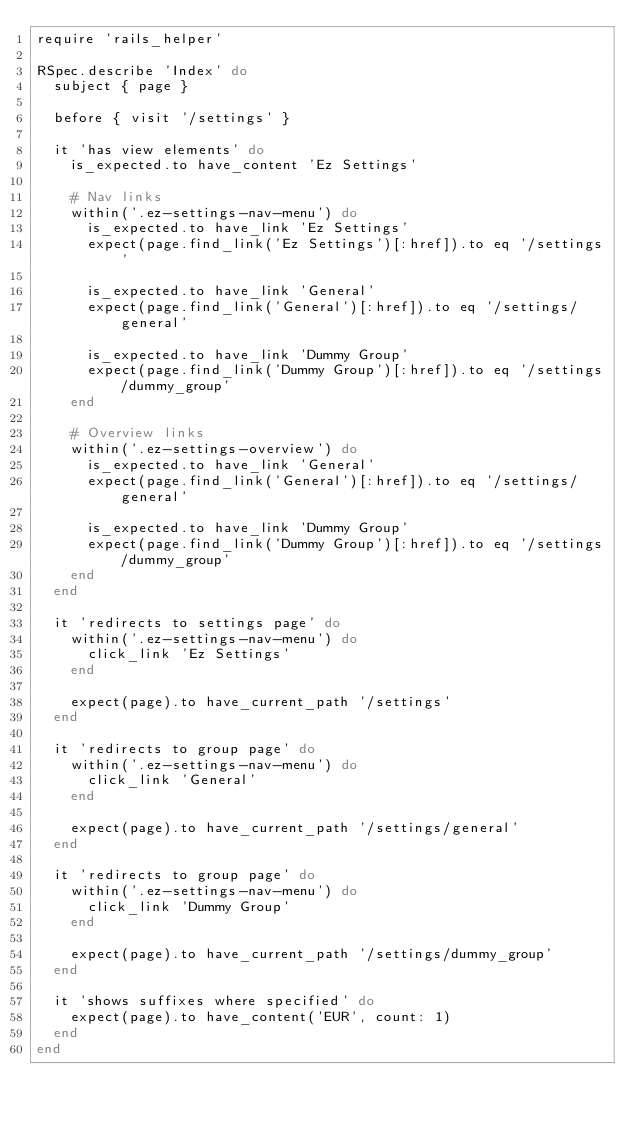<code> <loc_0><loc_0><loc_500><loc_500><_Ruby_>require 'rails_helper'

RSpec.describe 'Index' do
  subject { page }

  before { visit '/settings' }

  it 'has view elements' do
    is_expected.to have_content 'Ez Settings'

    # Nav links
    within('.ez-settings-nav-menu') do
      is_expected.to have_link 'Ez Settings'
      expect(page.find_link('Ez Settings')[:href]).to eq '/settings'

      is_expected.to have_link 'General'
      expect(page.find_link('General')[:href]).to eq '/settings/general'

      is_expected.to have_link 'Dummy Group'
      expect(page.find_link('Dummy Group')[:href]).to eq '/settings/dummy_group'
    end

    # Overview links
    within('.ez-settings-overview') do
      is_expected.to have_link 'General'
      expect(page.find_link('General')[:href]).to eq '/settings/general'

      is_expected.to have_link 'Dummy Group'
      expect(page.find_link('Dummy Group')[:href]).to eq '/settings/dummy_group'
    end
  end

  it 'redirects to settings page' do
    within('.ez-settings-nav-menu') do
      click_link 'Ez Settings'
    end

    expect(page).to have_current_path '/settings'
  end

  it 'redirects to group page' do
    within('.ez-settings-nav-menu') do
      click_link 'General'
    end

    expect(page).to have_current_path '/settings/general'
  end

  it 'redirects to group page' do
    within('.ez-settings-nav-menu') do
      click_link 'Dummy Group'
    end

    expect(page).to have_current_path '/settings/dummy_group'
  end

  it 'shows suffixes where specified' do
    expect(page).to have_content('EUR', count: 1)
  end
end
</code> 